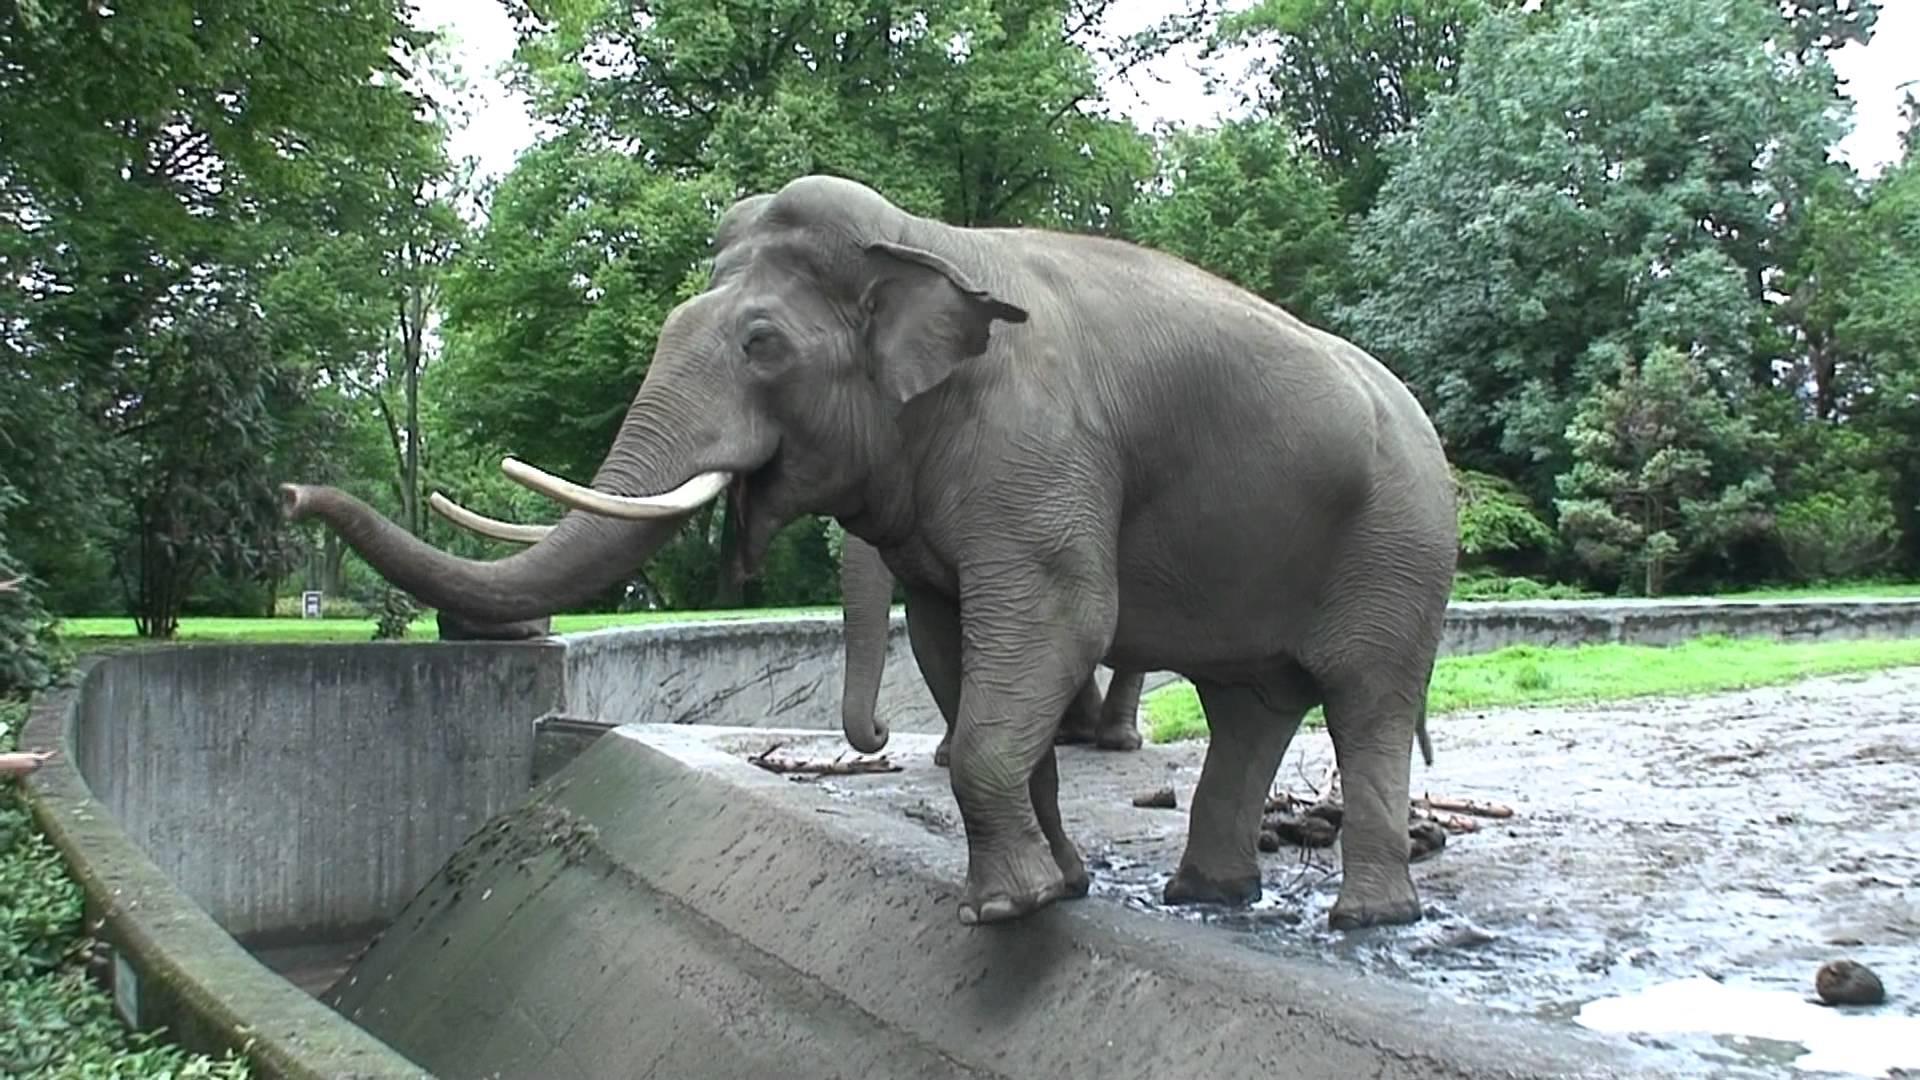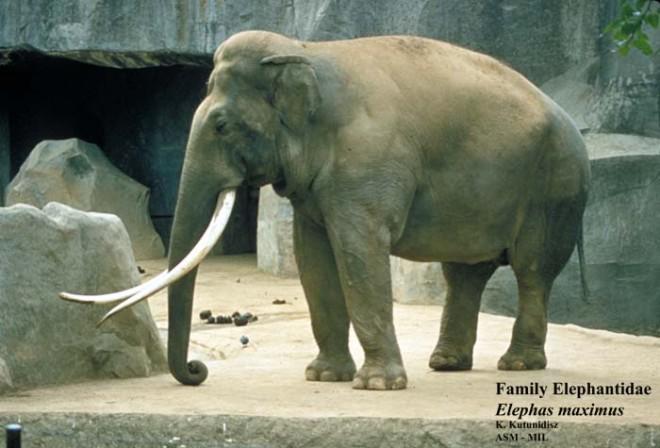The first image is the image on the left, the second image is the image on the right. For the images displayed, is the sentence "There is exactly one elephant facing left and exactly one elephant facing right." factually correct? Answer yes or no. No. 